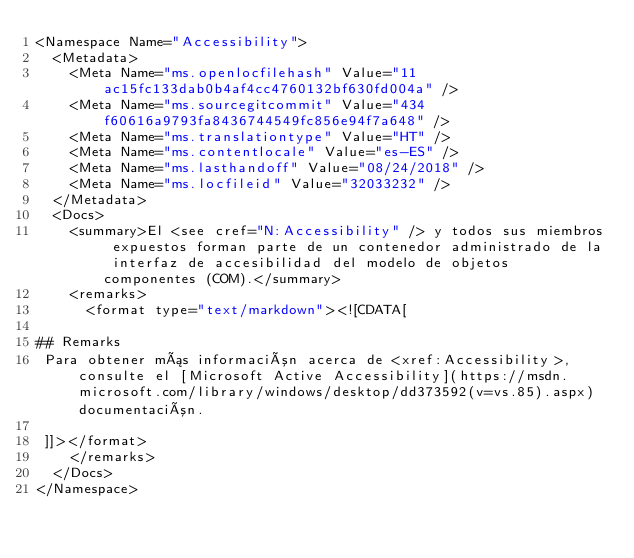Convert code to text. <code><loc_0><loc_0><loc_500><loc_500><_XML_><Namespace Name="Accessibility">
  <Metadata>
    <Meta Name="ms.openlocfilehash" Value="11ac15fc133dab0b4af4cc4760132bf630fd004a" />
    <Meta Name="ms.sourcegitcommit" Value="434f60616a9793fa8436744549fc856e94f7a648" />
    <Meta Name="ms.translationtype" Value="HT" />
    <Meta Name="ms.contentlocale" Value="es-ES" />
    <Meta Name="ms.lasthandoff" Value="08/24/2018" />
    <Meta Name="ms.locfileid" Value="32033232" />
  </Metadata>
  <Docs>
    <summary>El <see cref="N:Accessibility" /> y todos sus miembros expuestos forman parte de un contenedor administrado de la interfaz de accesibilidad del modelo de objetos componentes (COM).</summary>
    <remarks>
      <format type="text/markdown"><![CDATA[  
  
## Remarks  
 Para obtener más información acerca de <xref:Accessibility>, consulte el [Microsoft Active Accessibility](https://msdn.microsoft.com/library/windows/desktop/dd373592(v=vs.85).aspx) documentación.
  
 ]]></format>
    </remarks>
  </Docs>
</Namespace></code> 